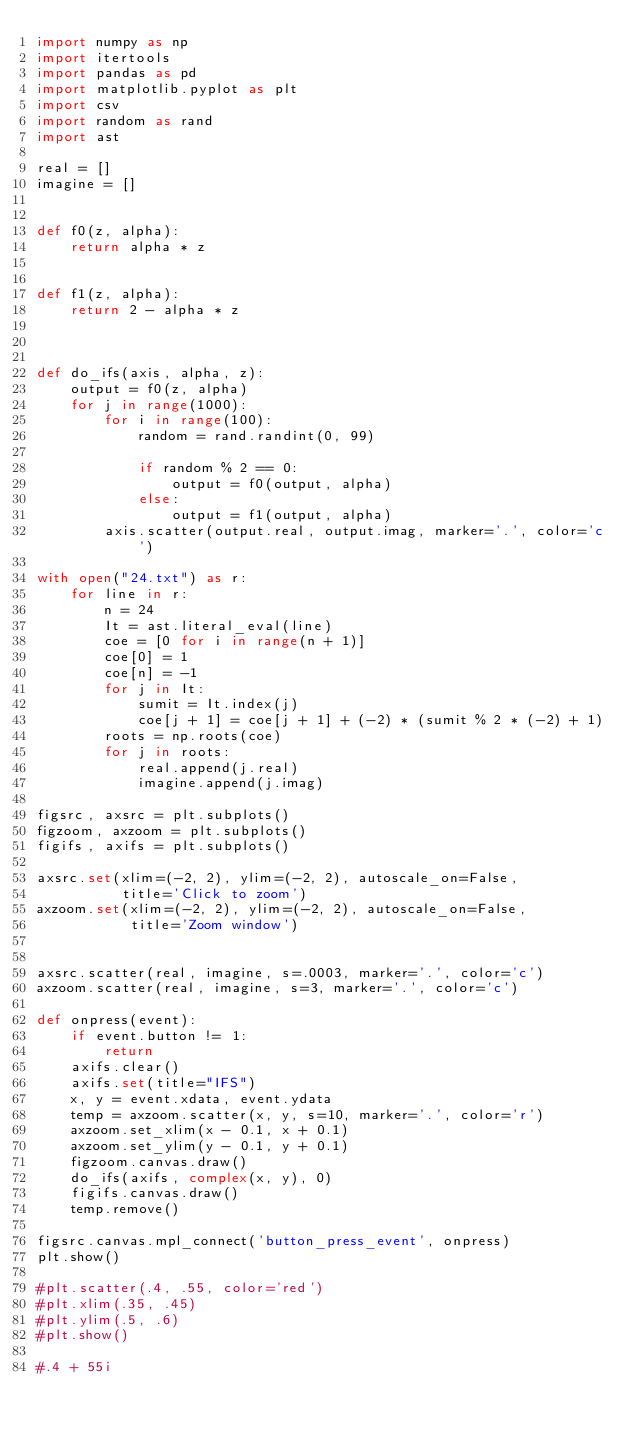Convert code to text. <code><loc_0><loc_0><loc_500><loc_500><_Python_>import numpy as np
import itertools
import pandas as pd
import matplotlib.pyplot as plt
import csv
import random as rand
import ast

real = []
imagine = []


def f0(z, alpha):
    return alpha * z


def f1(z, alpha):
    return 2 - alpha * z



def do_ifs(axis, alpha, z):
    output = f0(z, alpha)
    for j in range(1000):
        for i in range(100):
            random = rand.randint(0, 99)

            if random % 2 == 0:
                output = f0(output, alpha)
            else:
                output = f1(output, alpha)
        axis.scatter(output.real, output.imag, marker='.', color='c')

with open("24.txt") as r:
    for line in r:
        n = 24
        It = ast.literal_eval(line)
        coe = [0 for i in range(n + 1)]
        coe[0] = 1
        coe[n] = -1
        for j in It:
            sumit = It.index(j)
            coe[j + 1] = coe[j + 1] + (-2) * (sumit % 2 * (-2) + 1)
        roots = np.roots(coe)
        for j in roots:
            real.append(j.real)
            imagine.append(j.imag)

figsrc, axsrc = plt.subplots()
figzoom, axzoom = plt.subplots()
figifs, axifs = plt.subplots()

axsrc.set(xlim=(-2, 2), ylim=(-2, 2), autoscale_on=False,
          title='Click to zoom')
axzoom.set(xlim=(-2, 2), ylim=(-2, 2), autoscale_on=False,
           title='Zoom window')


axsrc.scatter(real, imagine, s=.0003, marker='.', color='c')
axzoom.scatter(real, imagine, s=3, marker='.', color='c')

def onpress(event):
    if event.button != 1:
        return
    axifs.clear()
    axifs.set(title="IFS")
    x, y = event.xdata, event.ydata
    temp = axzoom.scatter(x, y, s=10, marker='.', color='r')
    axzoom.set_xlim(x - 0.1, x + 0.1)
    axzoom.set_ylim(y - 0.1, y + 0.1)
    figzoom.canvas.draw()
    do_ifs(axifs, complex(x, y), 0)
    figifs.canvas.draw()
    temp.remove()

figsrc.canvas.mpl_connect('button_press_event', onpress)
plt.show()

#plt.scatter(.4, .55, color='red')
#plt.xlim(.35, .45)
#plt.ylim(.5, .6)
#plt.show()

#.4 + 55i</code> 